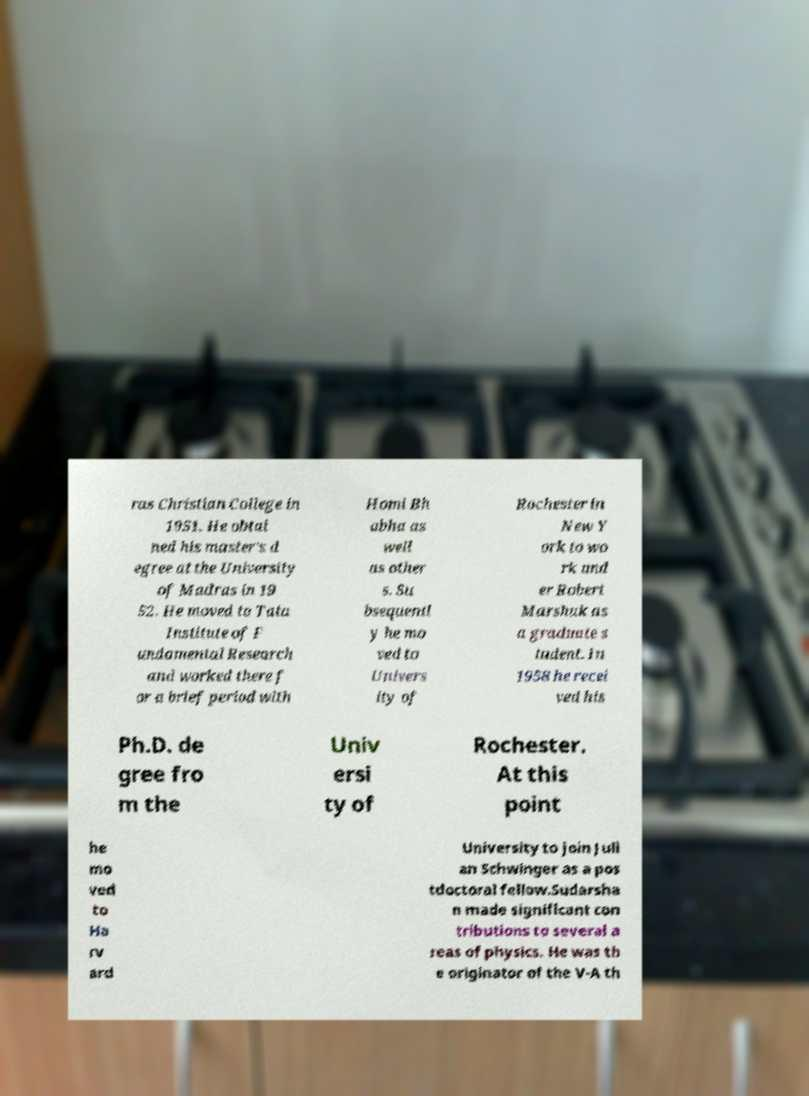What messages or text are displayed in this image? I need them in a readable, typed format. ras Christian College in 1951. He obtai ned his master's d egree at the University of Madras in 19 52. He moved to Tata Institute of F undamental Research and worked there f or a brief period with Homi Bh abha as well as other s. Su bsequentl y he mo ved to Univers ity of Rochester in New Y ork to wo rk und er Robert Marshak as a graduate s tudent. In 1958 he recei ved his Ph.D. de gree fro m the Univ ersi ty of Rochester. At this point he mo ved to Ha rv ard University to join Juli an Schwinger as a pos tdoctoral fellow.Sudarsha n made significant con tributions to several a reas of physics. He was th e originator of the V-A th 